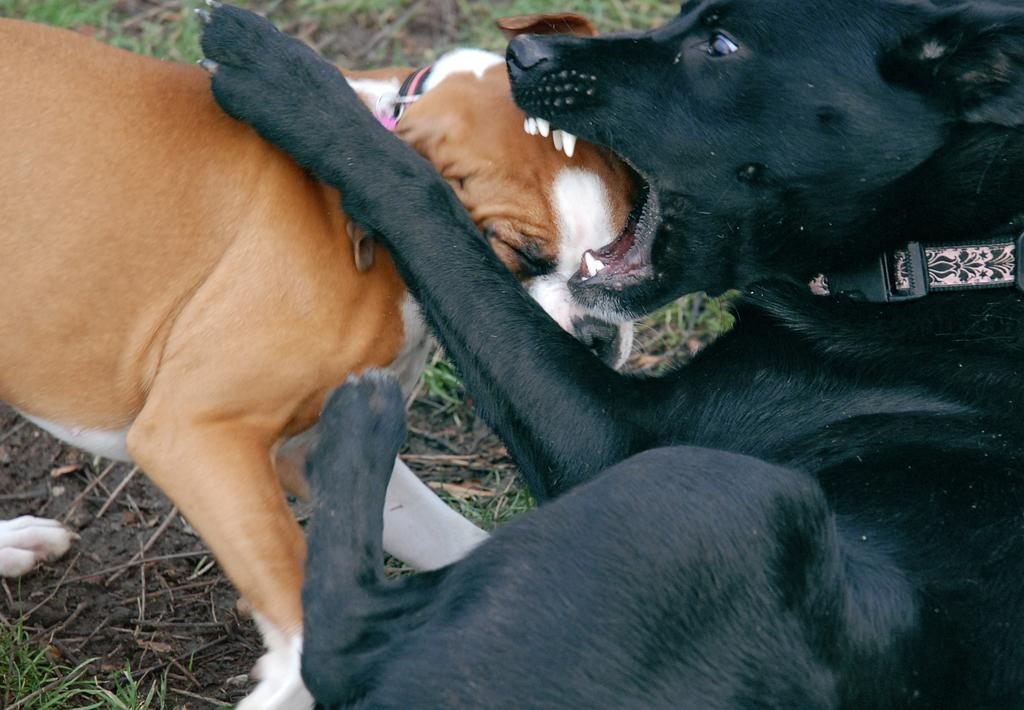How many dogs are present in the image? There are two dogs in the image. What are the dogs wearing? The dogs are wearing belts. What type of surface is visible on the ground? There is grass visible on the ground. What else can be seen on the ground besides grass? There are twigs on the ground. What time of day is it in the image, considering the presence of the afternoon? There is no mention of the afternoon or any specific time of day in the image. The image simply shows two dogs wearing belts, with grass and twigs on the ground. 